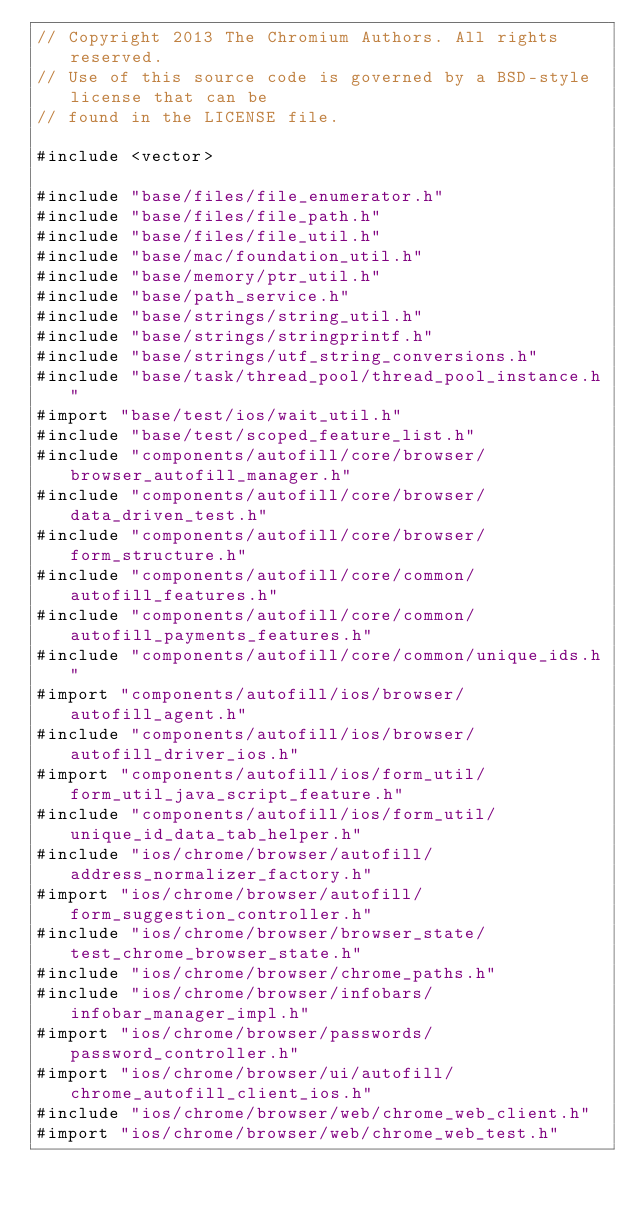<code> <loc_0><loc_0><loc_500><loc_500><_ObjectiveC_>// Copyright 2013 The Chromium Authors. All rights reserved.
// Use of this source code is governed by a BSD-style license that can be
// found in the LICENSE file.

#include <vector>

#include "base/files/file_enumerator.h"
#include "base/files/file_path.h"
#include "base/files/file_util.h"
#include "base/mac/foundation_util.h"
#include "base/memory/ptr_util.h"
#include "base/path_service.h"
#include "base/strings/string_util.h"
#include "base/strings/stringprintf.h"
#include "base/strings/utf_string_conversions.h"
#include "base/task/thread_pool/thread_pool_instance.h"
#import "base/test/ios/wait_util.h"
#include "base/test/scoped_feature_list.h"
#include "components/autofill/core/browser/browser_autofill_manager.h"
#include "components/autofill/core/browser/data_driven_test.h"
#include "components/autofill/core/browser/form_structure.h"
#include "components/autofill/core/common/autofill_features.h"
#include "components/autofill/core/common/autofill_payments_features.h"
#include "components/autofill/core/common/unique_ids.h"
#import "components/autofill/ios/browser/autofill_agent.h"
#include "components/autofill/ios/browser/autofill_driver_ios.h"
#import "components/autofill/ios/form_util/form_util_java_script_feature.h"
#include "components/autofill/ios/form_util/unique_id_data_tab_helper.h"
#include "ios/chrome/browser/autofill/address_normalizer_factory.h"
#import "ios/chrome/browser/autofill/form_suggestion_controller.h"
#include "ios/chrome/browser/browser_state/test_chrome_browser_state.h"
#include "ios/chrome/browser/chrome_paths.h"
#include "ios/chrome/browser/infobars/infobar_manager_impl.h"
#import "ios/chrome/browser/passwords/password_controller.h"
#import "ios/chrome/browser/ui/autofill/chrome_autofill_client_ios.h"
#include "ios/chrome/browser/web/chrome_web_client.h"
#import "ios/chrome/browser/web/chrome_web_test.h"</code> 